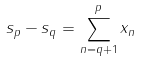Convert formula to latex. <formula><loc_0><loc_0><loc_500><loc_500>s _ { p } - s _ { q } = \sum _ { n = q + 1 } ^ { p } x _ { n }</formula> 